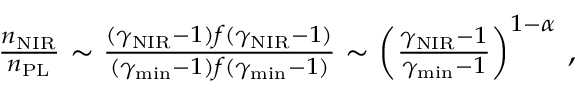<formula> <loc_0><loc_0><loc_500><loc_500>\begin{array} { r } { \frac { n _ { N I R } } { n _ { P L } } \sim \frac { ( \gamma _ { N I R } - 1 ) f ( \gamma _ { N I R } - 1 ) } { ( \gamma _ { \min } - 1 ) f ( \gamma _ { \min } - 1 ) } \sim \left ( \frac { \gamma _ { N I R } - 1 } { \gamma _ { \min } - 1 } \right ) ^ { 1 - \alpha } \, , } \end{array}</formula> 